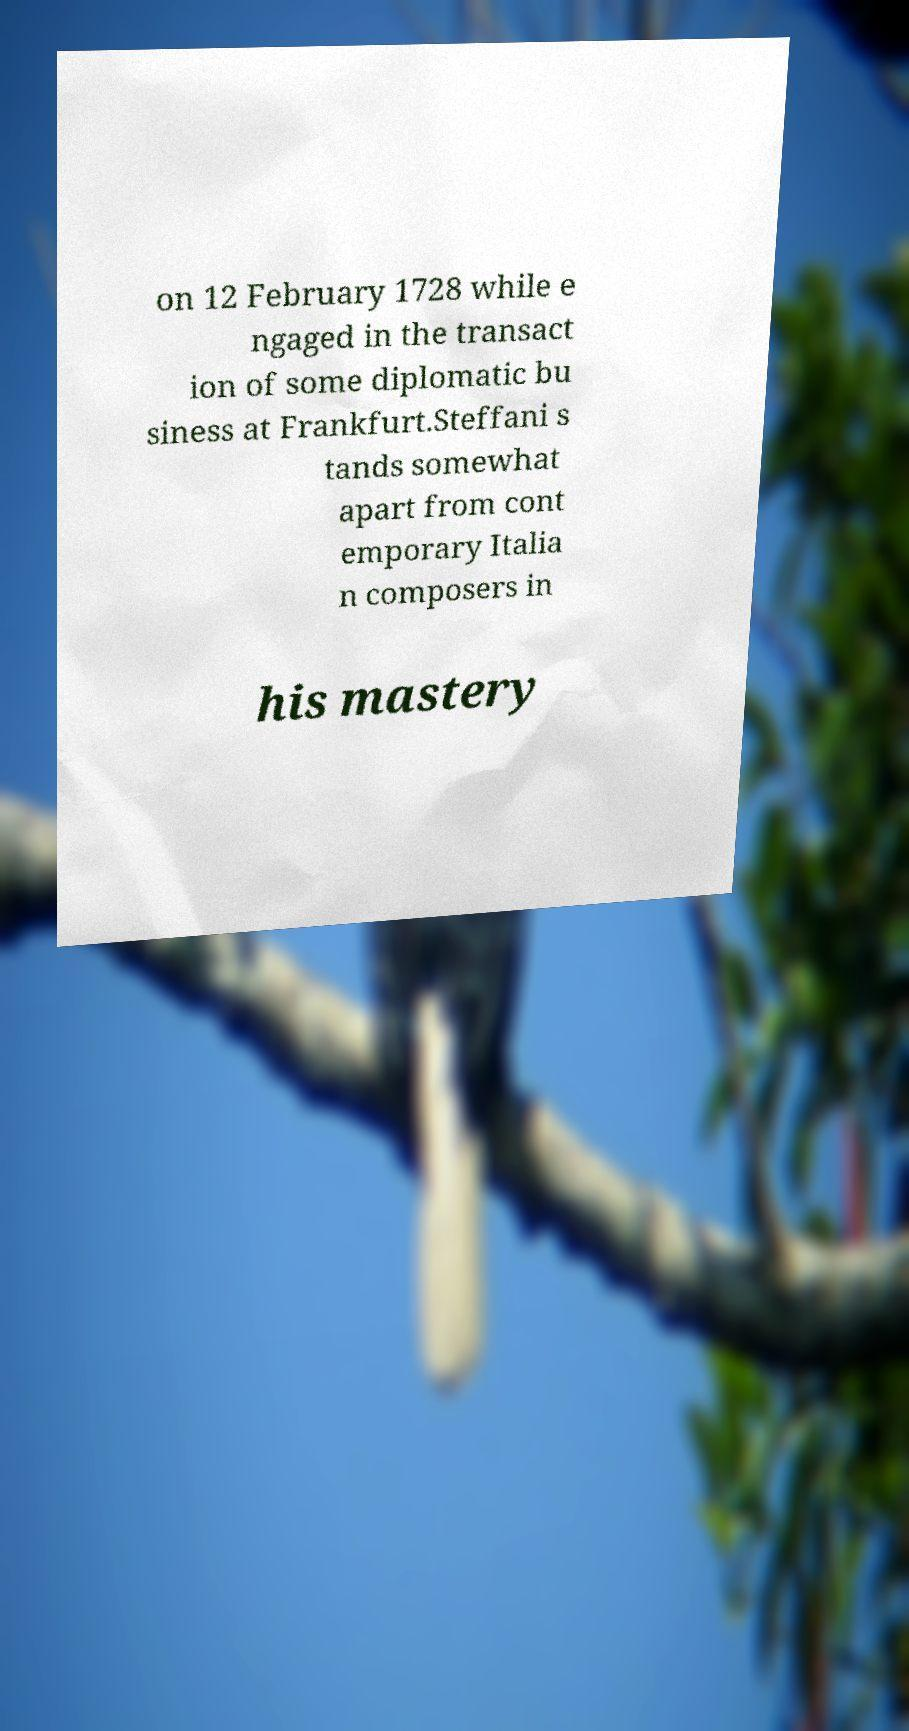There's text embedded in this image that I need extracted. Can you transcribe it verbatim? on 12 February 1728 while e ngaged in the transact ion of some diplomatic bu siness at Frankfurt.Steffani s tands somewhat apart from cont emporary Italia n composers in his mastery 